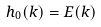Convert formula to latex. <formula><loc_0><loc_0><loc_500><loc_500>h _ { 0 } ( k ) = E ( k )</formula> 